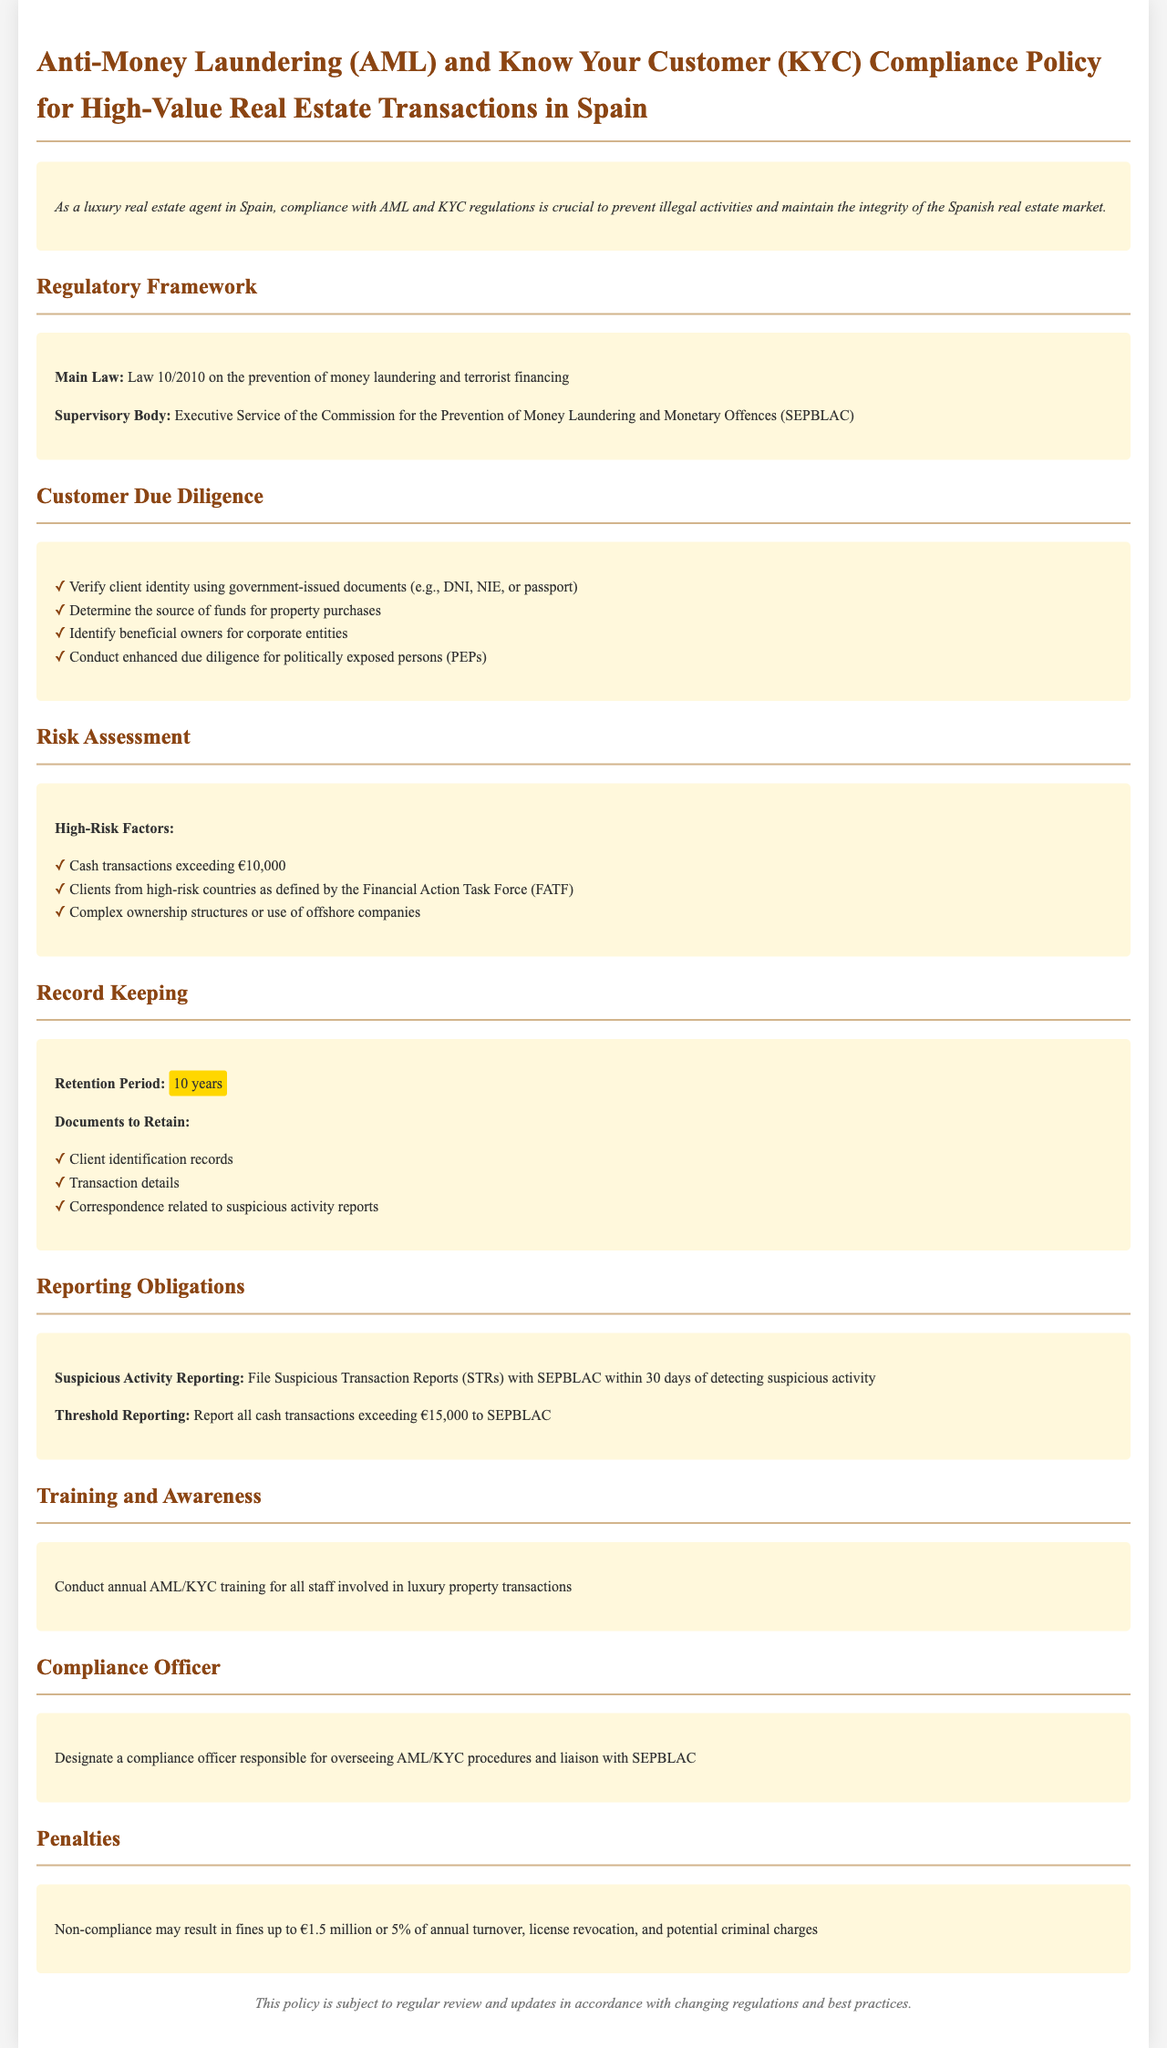What is the main law related to AML and KYC? The main law outlined in the document is Law 10/2010, which focuses on the prevention of money laundering and terrorist financing.
Answer: Law 10/2010 Who is the supervisory body for AML compliance? The document specifies that the supervisory body responsible for AML compliance is SEPBLAC.
Answer: SEPBLAC What is the retention period for records? The policy states that records must be retained for a period of 10 years.
Answer: 10 years What is one of the high-risk factors for transactions? One of the high-risk factors mentioned is cash transactions exceeding €10,000.
Answer: Cash transactions exceeding €10,000 What must be reported within 30 days? According to the document, Suspicious Transaction Reports (STRs) must be filed within 30 days of detecting suspicious activity.
Answer: Suspicious Transaction Reports (STRs) What is the penalty for non-compliance? The document states that non-compliance may result in fines up to €1.5 million or 5% of annual turnover.
Answer: €1.5 million or 5% of annual turnover What type of training is required annually? The policy mandates annual AML/KYC training for all staff involved in luxury property transactions.
Answer: Annual AML/KYC training Who is responsible for overseeing AML/KYC procedures? The document designates a compliance officer as responsible for overseeing AML/KYC procedures.
Answer: Compliance officer What should be done if suspicious activity is detected? The document states that suspicious activity must be reported by filing STRs with SEPBLAC.
Answer: File STRs with SEPBLAC 